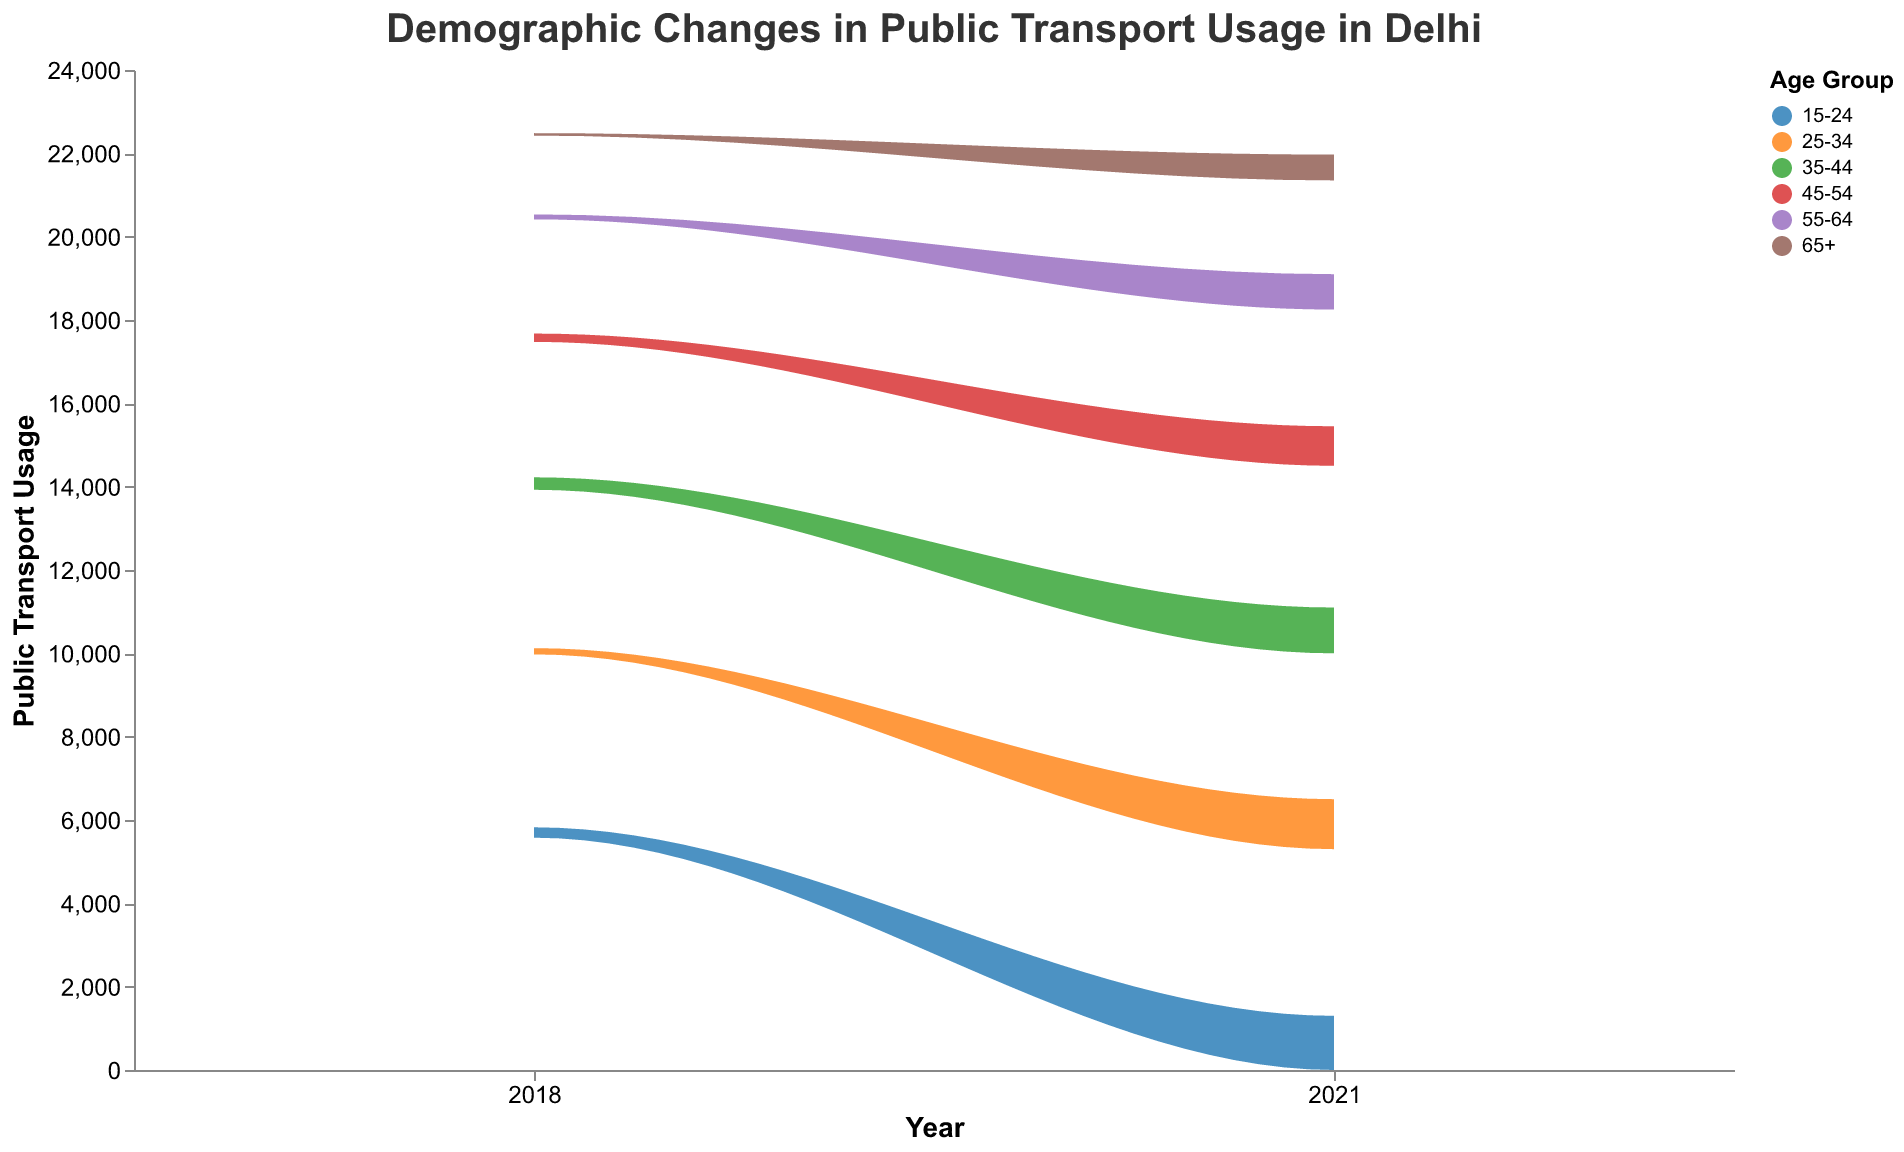What is the title of the graph? The title of the graph is found at the top and usually provides a high-level summary of what the graph represents. Here, it states: "Demographic Changes in Public Transport Usage in Delhi".
Answer: Demographic Changes in Public Transport Usage in Delhi Which age group uses public transport the most in 2018? Looking at the stream graph, identify which color band representing an age group is the largest in terms of vertical thickness in the year 2018.
Answer: 15-24 Did the public transport usage for the age group 35-44 increase or decrease from 2018 to 2021? Compare the thickness of the stream at the 2018 and 2021 positions for the color corresponding to the 35-44 age group. Check if it increased or decreased.
Answer: Increase Which gender has higher low-income group public transport usage across all years? Examine the two sections of the stream corresponding to low-income groups for both males and females and compare their total thickness.
Answer: Female For the year 2021, which income group within the 25-34 age range uses public transport the least? Look at the segments for age group 25-34 in 2021 and compare the thickness of the stream for low, middle, and high-income groups. Identify the smallest segment.
Answer: High Income How has the public transport usage trend changed for the 65+ age group from 2018 to 2021? Analyze the stream thickness in the 2018 and 2021 regions for the 65+ age group color. Assess whether there's an increase or decrease.
Answer: Increase Which age group saw the most significant change in public transport usage between 2018 and 2021? Compare the differences in thickness from 2018 to 2021 for all age groups to determine which one had the most drastic change.
Answer: 15-24 Was there an increase or decrease in public transport usage for middle-income females in the 55-64 age range from 2018 to 2021? Check the stream thickness for middle-income females aged 55-64 in both years 2018 and 2021 and note the change.
Answer: Increase Compare the total public transport usage in 2018 and 2021. Did the overall usage go up or down? Sum the thickness of the entire stream graph for both years and compare the overall total public transport usage between 2018 and 2021.
Answer: Increase Which age group's stream color typically appears at the bottom of the graph? Identify the color coding for the different age groups and see which one is consistently placed at the bottom of the stream in both years.
Answer: 15-24 